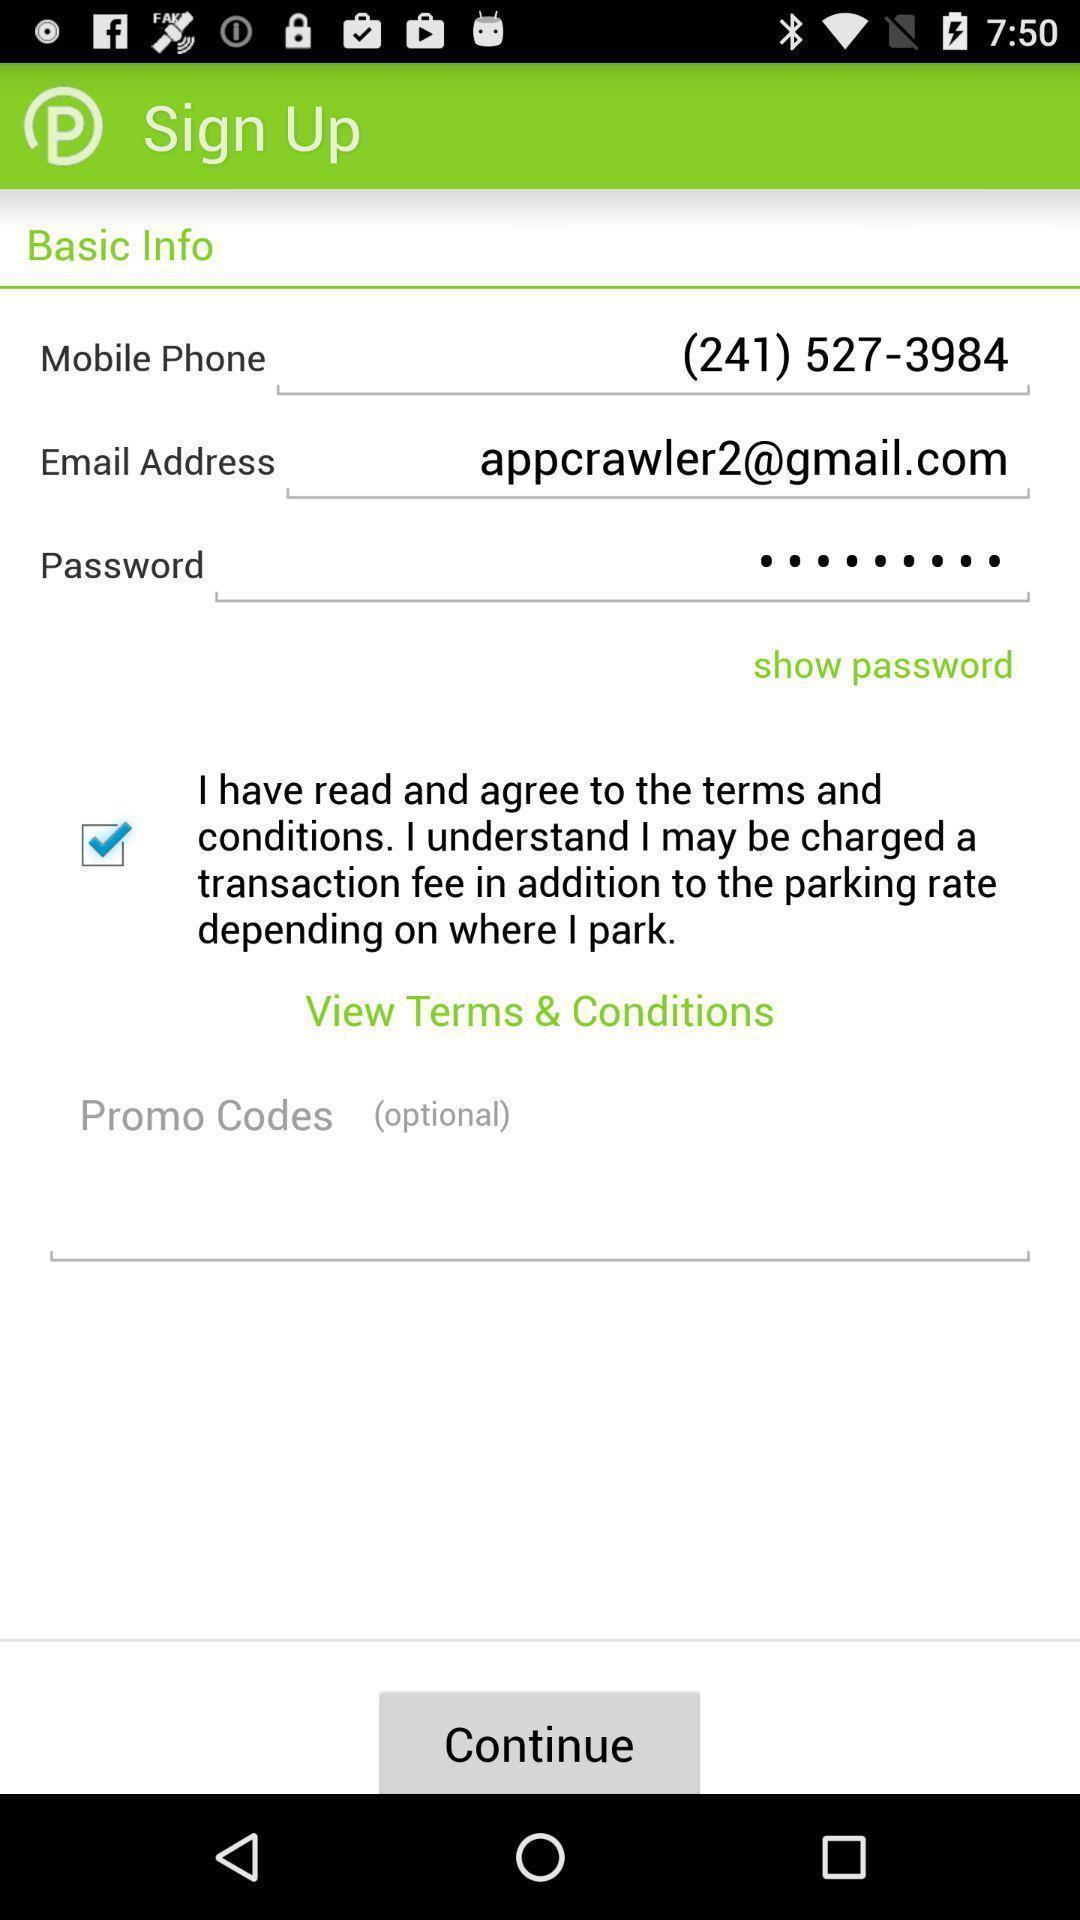What details can you identify in this image? Sign up page. 